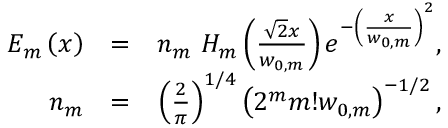Convert formula to latex. <formula><loc_0><loc_0><loc_500><loc_500>\begin{array} { r l r } { E _ { m } \left ( x \right ) } & { = } & { n _ { m } H _ { m } \left ( \frac { \sqrt { 2 } x } { w _ { 0 , m } } \right ) e ^ { - \left ( \frac { x } { w _ { 0 , m } } \right ) ^ { 2 } } , } \\ { n _ { m } } & { = } & { \left ( \frac { 2 } { \pi } \right ) ^ { 1 / 4 } \left ( 2 ^ { m } m ! w _ { 0 , m } \right ) ^ { - 1 / 2 } , } \end{array}</formula> 